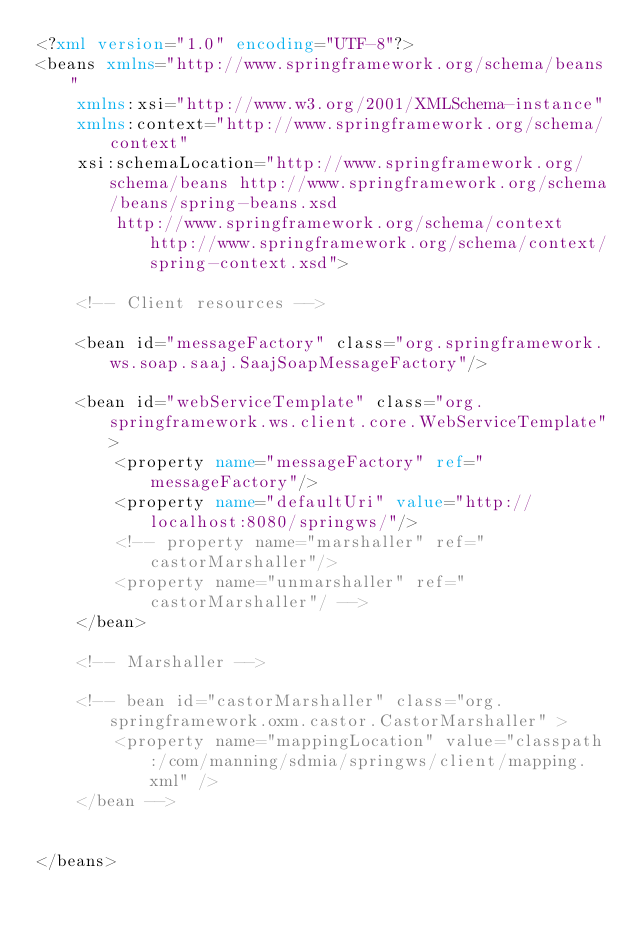<code> <loc_0><loc_0><loc_500><loc_500><_XML_><?xml version="1.0" encoding="UTF-8"?>
<beans xmlns="http://www.springframework.org/schema/beans"
	xmlns:xsi="http://www.w3.org/2001/XMLSchema-instance"
	xmlns:context="http://www.springframework.org/schema/context"
	xsi:schemaLocation="http://www.springframework.org/schema/beans http://www.springframework.org/schema/beans/spring-beans.xsd
		http://www.springframework.org/schema/context http://www.springframework.org/schema/context/spring-context.xsd">

	<!-- Client resources -->

    <bean id="messageFactory" class="org.springframework.ws.soap.saaj.SaajSoapMessageFactory"/>

    <bean id="webServiceTemplate" class="org.springframework.ws.client.core.WebServiceTemplate">
        <property name="messageFactory" ref="messageFactory"/>
        <property name="defaultUri" value="http://localhost:8080/springws/"/>
        <!-- property name="marshaller" ref="castorMarshaller"/>
        <property name="unmarshaller" ref="castorMarshaller"/ -->
    </bean>
    
    <!-- Marshaller -->

	<!-- bean id="castorMarshaller" class="org.springframework.oxm.castor.CastorMarshaller" >
        <property name="mappingLocation" value="classpath:/com/manning/sdmia/springws/client/mapping.xml" />
    </bean -->
    
    
</beans>
</code> 